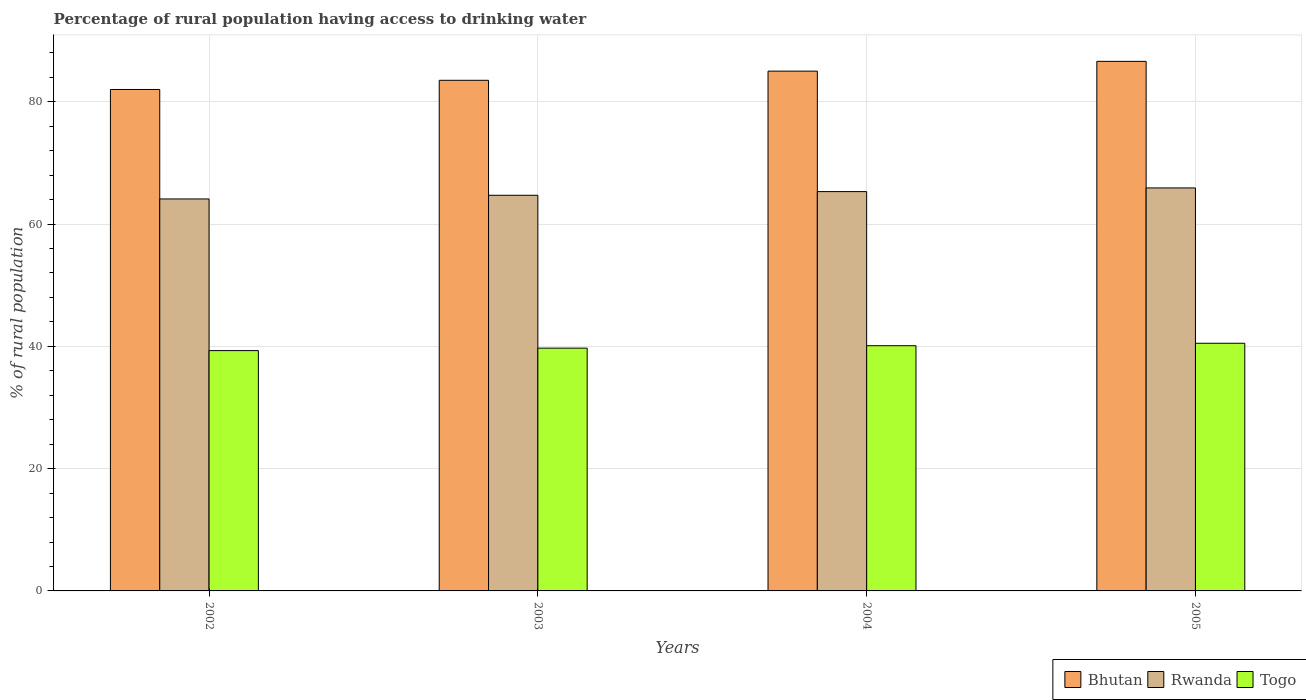How many groups of bars are there?
Offer a very short reply. 4. Are the number of bars on each tick of the X-axis equal?
Your answer should be compact. Yes. How many bars are there on the 4th tick from the left?
Your response must be concise. 3. In how many cases, is the number of bars for a given year not equal to the number of legend labels?
Offer a very short reply. 0. What is the percentage of rural population having access to drinking water in Bhutan in 2002?
Make the answer very short. 82. Across all years, what is the maximum percentage of rural population having access to drinking water in Bhutan?
Your response must be concise. 86.6. In which year was the percentage of rural population having access to drinking water in Togo maximum?
Provide a short and direct response. 2005. In which year was the percentage of rural population having access to drinking water in Bhutan minimum?
Your answer should be compact. 2002. What is the total percentage of rural population having access to drinking water in Rwanda in the graph?
Give a very brief answer. 260. What is the difference between the percentage of rural population having access to drinking water in Togo in 2005 and the percentage of rural population having access to drinking water in Rwanda in 2002?
Your answer should be very brief. -23.6. What is the average percentage of rural population having access to drinking water in Rwanda per year?
Provide a succinct answer. 65. In the year 2002, what is the difference between the percentage of rural population having access to drinking water in Bhutan and percentage of rural population having access to drinking water in Togo?
Offer a terse response. 42.7. In how many years, is the percentage of rural population having access to drinking water in Rwanda greater than 52 %?
Your answer should be compact. 4. What is the ratio of the percentage of rural population having access to drinking water in Rwanda in 2003 to that in 2005?
Keep it short and to the point. 0.98. Is the percentage of rural population having access to drinking water in Rwanda in 2004 less than that in 2005?
Your answer should be compact. Yes. What is the difference between the highest and the second highest percentage of rural population having access to drinking water in Togo?
Your answer should be very brief. 0.4. What is the difference between the highest and the lowest percentage of rural population having access to drinking water in Bhutan?
Keep it short and to the point. 4.6. What does the 2nd bar from the left in 2003 represents?
Give a very brief answer. Rwanda. What does the 2nd bar from the right in 2003 represents?
Offer a terse response. Rwanda. Are all the bars in the graph horizontal?
Offer a terse response. No. How many years are there in the graph?
Your response must be concise. 4. Are the values on the major ticks of Y-axis written in scientific E-notation?
Give a very brief answer. No. Does the graph contain any zero values?
Ensure brevity in your answer.  No. How many legend labels are there?
Keep it short and to the point. 3. How are the legend labels stacked?
Offer a terse response. Horizontal. What is the title of the graph?
Keep it short and to the point. Percentage of rural population having access to drinking water. What is the label or title of the X-axis?
Your answer should be very brief. Years. What is the label or title of the Y-axis?
Give a very brief answer. % of rural population. What is the % of rural population of Rwanda in 2002?
Keep it short and to the point. 64.1. What is the % of rural population of Togo in 2002?
Offer a terse response. 39.3. What is the % of rural population in Bhutan in 2003?
Provide a short and direct response. 83.5. What is the % of rural population in Rwanda in 2003?
Give a very brief answer. 64.7. What is the % of rural population in Togo in 2003?
Provide a short and direct response. 39.7. What is the % of rural population of Rwanda in 2004?
Keep it short and to the point. 65.3. What is the % of rural population of Togo in 2004?
Provide a succinct answer. 40.1. What is the % of rural population in Bhutan in 2005?
Provide a short and direct response. 86.6. What is the % of rural population of Rwanda in 2005?
Give a very brief answer. 65.9. What is the % of rural population in Togo in 2005?
Offer a very short reply. 40.5. Across all years, what is the maximum % of rural population of Bhutan?
Keep it short and to the point. 86.6. Across all years, what is the maximum % of rural population of Rwanda?
Provide a short and direct response. 65.9. Across all years, what is the maximum % of rural population in Togo?
Offer a very short reply. 40.5. Across all years, what is the minimum % of rural population in Bhutan?
Your response must be concise. 82. Across all years, what is the minimum % of rural population in Rwanda?
Give a very brief answer. 64.1. Across all years, what is the minimum % of rural population of Togo?
Provide a short and direct response. 39.3. What is the total % of rural population of Bhutan in the graph?
Your response must be concise. 337.1. What is the total % of rural population of Rwanda in the graph?
Provide a succinct answer. 260. What is the total % of rural population in Togo in the graph?
Ensure brevity in your answer.  159.6. What is the difference between the % of rural population in Bhutan in 2002 and that in 2003?
Provide a succinct answer. -1.5. What is the difference between the % of rural population in Rwanda in 2002 and that in 2003?
Give a very brief answer. -0.6. What is the difference between the % of rural population in Togo in 2002 and that in 2003?
Offer a very short reply. -0.4. What is the difference between the % of rural population in Rwanda in 2002 and that in 2004?
Your answer should be compact. -1.2. What is the difference between the % of rural population of Rwanda in 2002 and that in 2005?
Offer a very short reply. -1.8. What is the difference between the % of rural population in Togo in 2002 and that in 2005?
Offer a very short reply. -1.2. What is the difference between the % of rural population in Rwanda in 2004 and that in 2005?
Offer a terse response. -0.6. What is the difference between the % of rural population in Togo in 2004 and that in 2005?
Your answer should be very brief. -0.4. What is the difference between the % of rural population of Bhutan in 2002 and the % of rural population of Togo in 2003?
Your answer should be very brief. 42.3. What is the difference between the % of rural population of Rwanda in 2002 and the % of rural population of Togo in 2003?
Keep it short and to the point. 24.4. What is the difference between the % of rural population in Bhutan in 2002 and the % of rural population in Togo in 2004?
Your answer should be compact. 41.9. What is the difference between the % of rural population in Rwanda in 2002 and the % of rural population in Togo in 2004?
Provide a succinct answer. 24. What is the difference between the % of rural population in Bhutan in 2002 and the % of rural population in Rwanda in 2005?
Make the answer very short. 16.1. What is the difference between the % of rural population of Bhutan in 2002 and the % of rural population of Togo in 2005?
Provide a succinct answer. 41.5. What is the difference between the % of rural population in Rwanda in 2002 and the % of rural population in Togo in 2005?
Offer a very short reply. 23.6. What is the difference between the % of rural population of Bhutan in 2003 and the % of rural population of Rwanda in 2004?
Provide a succinct answer. 18.2. What is the difference between the % of rural population in Bhutan in 2003 and the % of rural population in Togo in 2004?
Provide a succinct answer. 43.4. What is the difference between the % of rural population of Rwanda in 2003 and the % of rural population of Togo in 2004?
Your answer should be compact. 24.6. What is the difference between the % of rural population of Bhutan in 2003 and the % of rural population of Togo in 2005?
Provide a short and direct response. 43. What is the difference between the % of rural population in Rwanda in 2003 and the % of rural population in Togo in 2005?
Provide a short and direct response. 24.2. What is the difference between the % of rural population of Bhutan in 2004 and the % of rural population of Togo in 2005?
Keep it short and to the point. 44.5. What is the difference between the % of rural population of Rwanda in 2004 and the % of rural population of Togo in 2005?
Keep it short and to the point. 24.8. What is the average % of rural population in Bhutan per year?
Your answer should be compact. 84.28. What is the average % of rural population in Rwanda per year?
Offer a very short reply. 65. What is the average % of rural population in Togo per year?
Give a very brief answer. 39.9. In the year 2002, what is the difference between the % of rural population of Bhutan and % of rural population of Togo?
Your response must be concise. 42.7. In the year 2002, what is the difference between the % of rural population in Rwanda and % of rural population in Togo?
Provide a succinct answer. 24.8. In the year 2003, what is the difference between the % of rural population in Bhutan and % of rural population in Togo?
Offer a terse response. 43.8. In the year 2004, what is the difference between the % of rural population in Bhutan and % of rural population in Togo?
Offer a terse response. 44.9. In the year 2004, what is the difference between the % of rural population in Rwanda and % of rural population in Togo?
Offer a very short reply. 25.2. In the year 2005, what is the difference between the % of rural population in Bhutan and % of rural population in Rwanda?
Give a very brief answer. 20.7. In the year 2005, what is the difference between the % of rural population of Bhutan and % of rural population of Togo?
Offer a terse response. 46.1. In the year 2005, what is the difference between the % of rural population in Rwanda and % of rural population in Togo?
Your answer should be compact. 25.4. What is the ratio of the % of rural population in Togo in 2002 to that in 2003?
Give a very brief answer. 0.99. What is the ratio of the % of rural population of Bhutan in 2002 to that in 2004?
Keep it short and to the point. 0.96. What is the ratio of the % of rural population in Rwanda in 2002 to that in 2004?
Offer a terse response. 0.98. What is the ratio of the % of rural population of Bhutan in 2002 to that in 2005?
Make the answer very short. 0.95. What is the ratio of the % of rural population of Rwanda in 2002 to that in 2005?
Make the answer very short. 0.97. What is the ratio of the % of rural population of Togo in 2002 to that in 2005?
Provide a short and direct response. 0.97. What is the ratio of the % of rural population of Bhutan in 2003 to that in 2004?
Provide a short and direct response. 0.98. What is the ratio of the % of rural population of Bhutan in 2003 to that in 2005?
Your answer should be very brief. 0.96. What is the ratio of the % of rural population in Rwanda in 2003 to that in 2005?
Keep it short and to the point. 0.98. What is the ratio of the % of rural population in Togo in 2003 to that in 2005?
Make the answer very short. 0.98. What is the ratio of the % of rural population in Bhutan in 2004 to that in 2005?
Your answer should be compact. 0.98. What is the ratio of the % of rural population in Rwanda in 2004 to that in 2005?
Your answer should be very brief. 0.99. What is the ratio of the % of rural population of Togo in 2004 to that in 2005?
Offer a terse response. 0.99. What is the difference between the highest and the second highest % of rural population in Bhutan?
Keep it short and to the point. 1.6. What is the difference between the highest and the second highest % of rural population of Togo?
Your answer should be very brief. 0.4. What is the difference between the highest and the lowest % of rural population in Bhutan?
Your response must be concise. 4.6. 